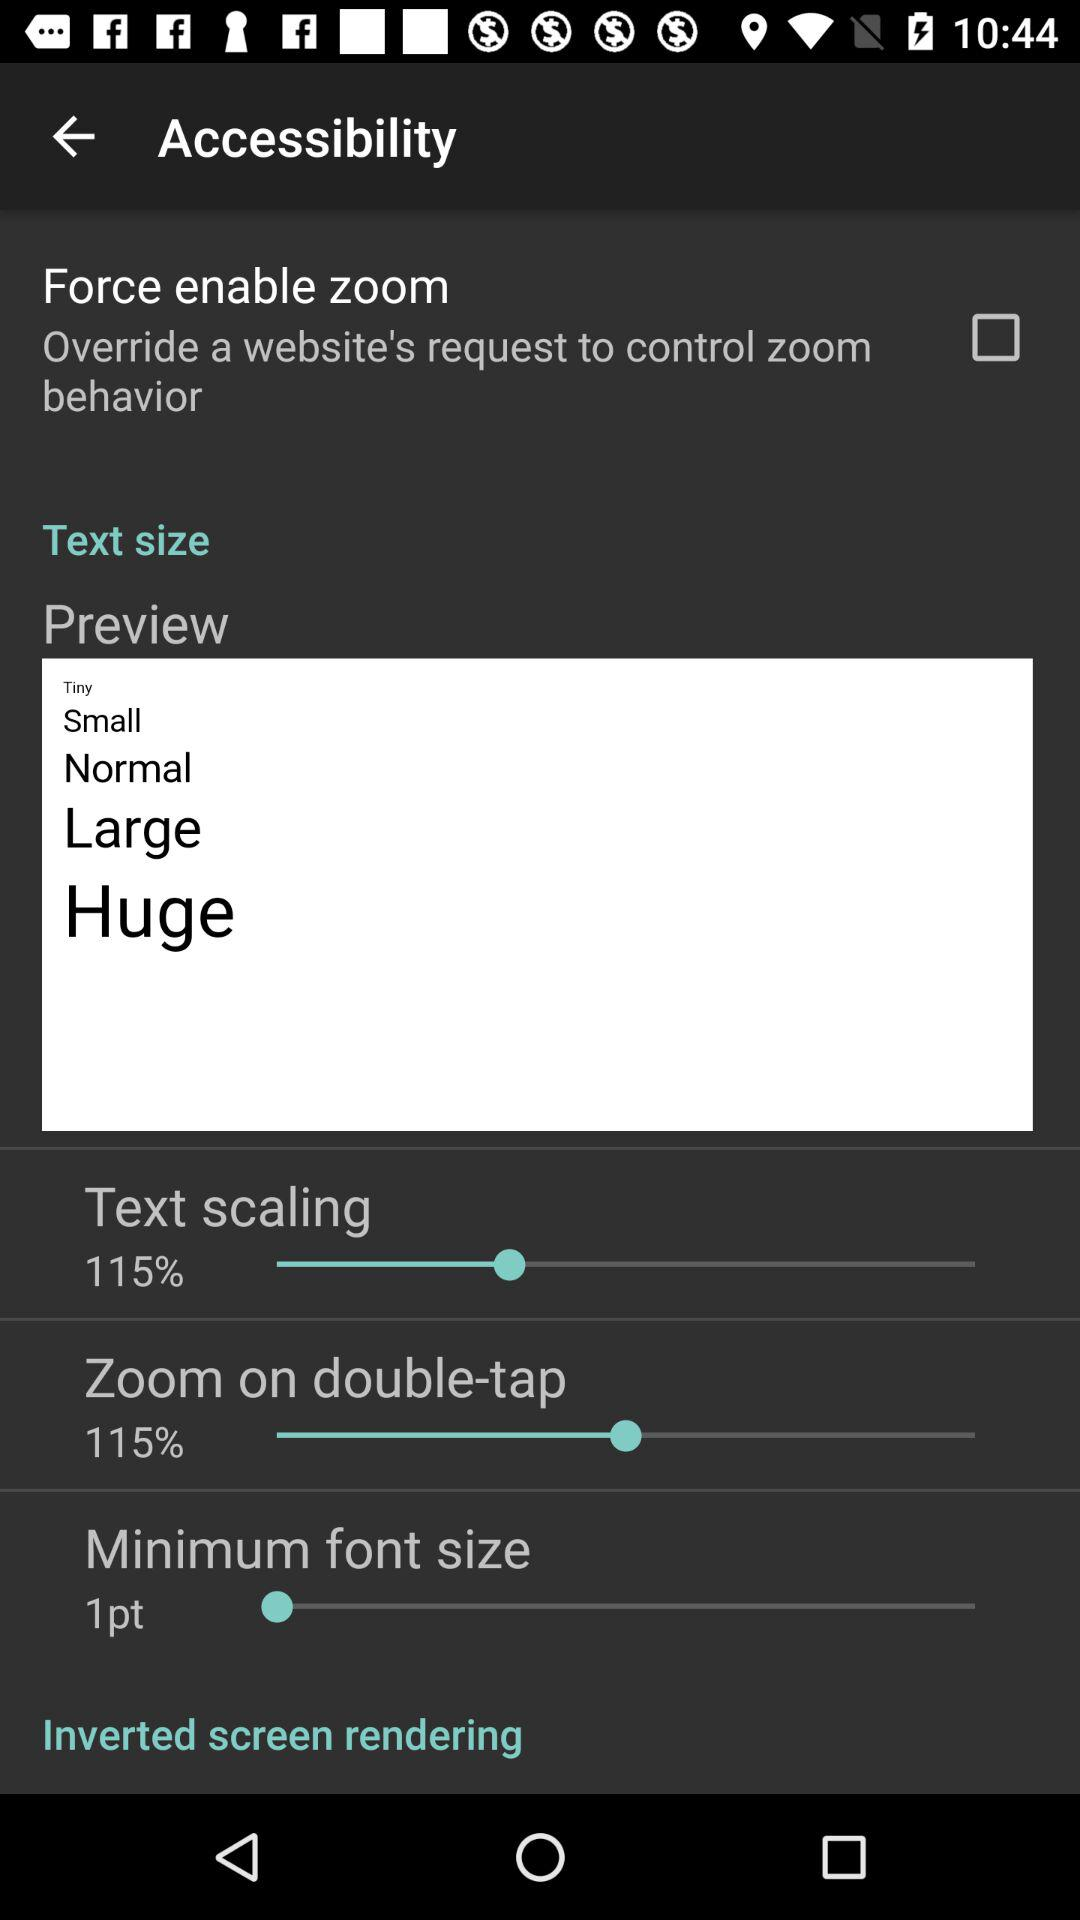What is the percentage of zoom on double-tap? The percentage of zoom on double-tap is 115. 